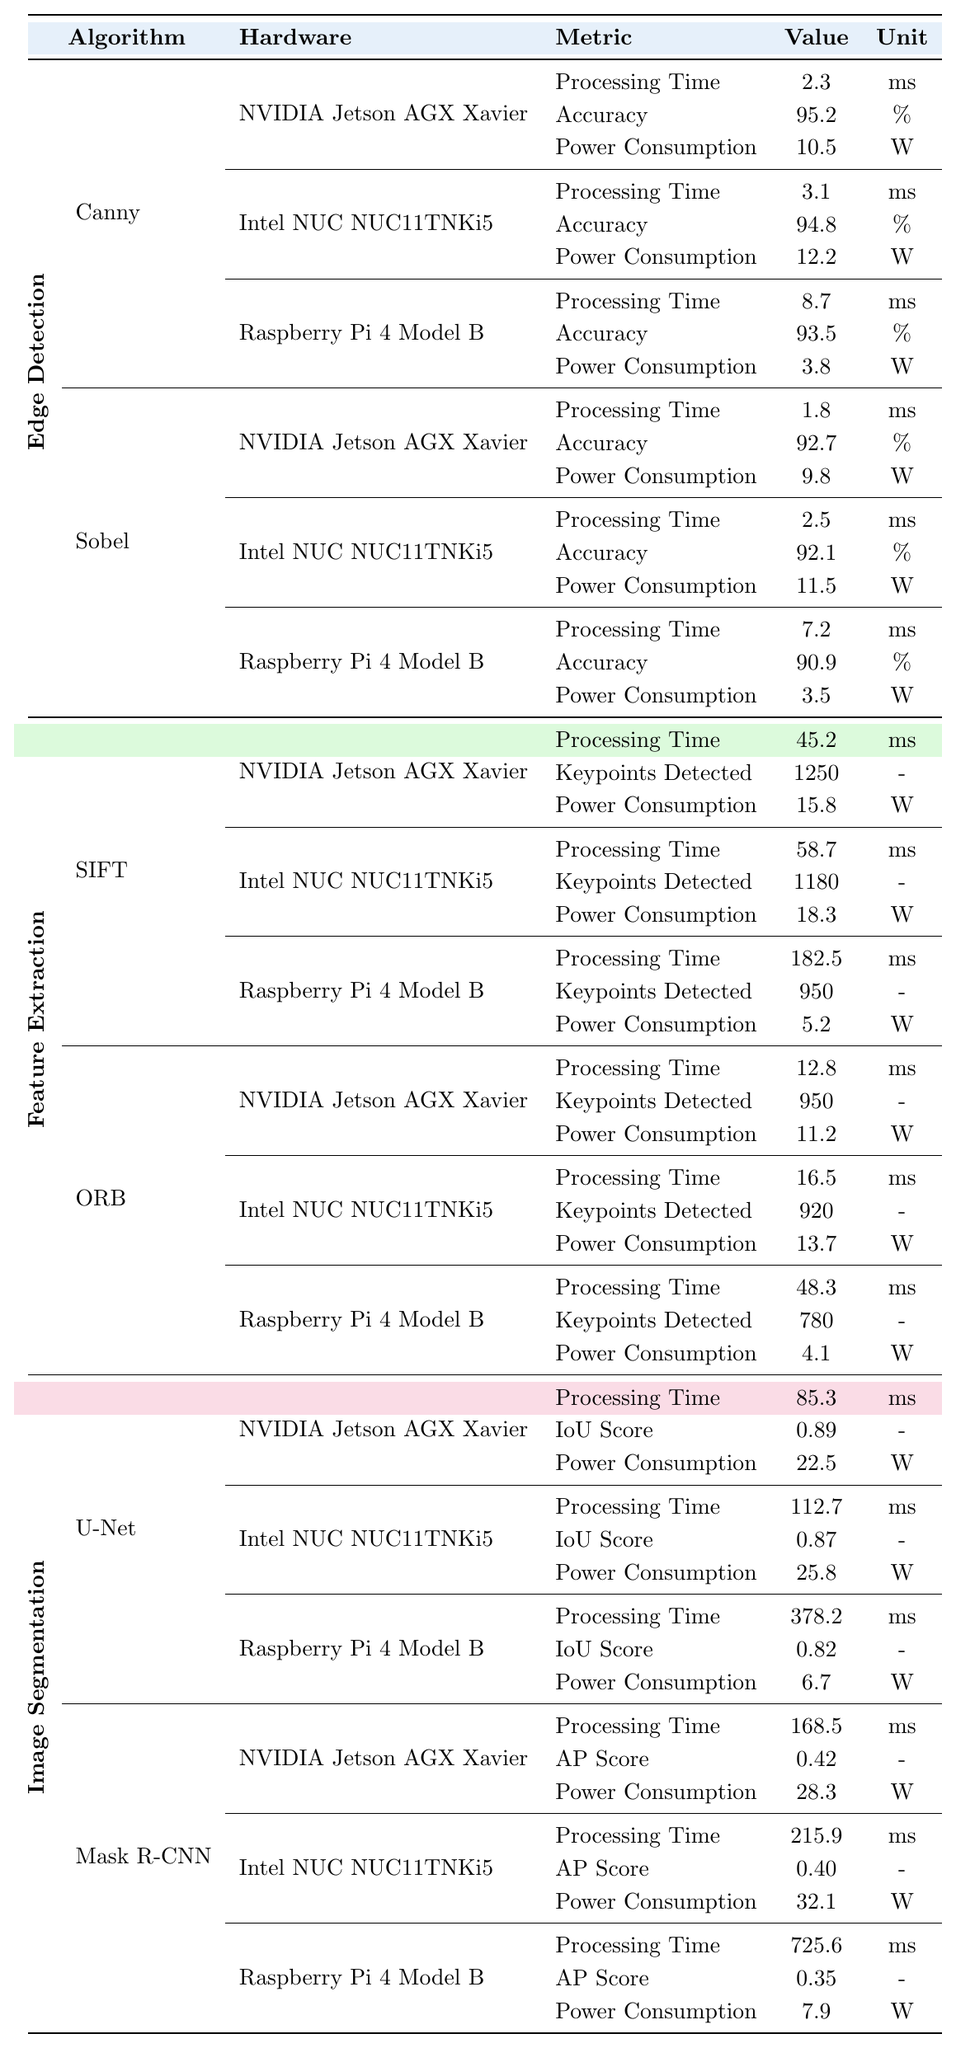What's the processing time of the Canny algorithm on the NVIDIA Jetson AGX Xavier? The table shows that the processing time for the Canny algorithm on the NVIDIA Jetson AGX Xavier is 2.3 ms.
Answer: 2.3 ms Which algorithm has the highest accuracy among the edge detection algorithms? By comparing the accuracy values for Canny (95.2%), and Sobel (92.7%), the Canny algorithm has the highest accuracy among edge detection algorithms.
Answer: Canny What is the power consumption for the Mask R-CNN algorithm on the Raspberry Pi 4 Model B? The power consumption for the Mask R-CNN algorithm on the Raspberry Pi 4 Model B is noted as 7.9 W in the table.
Answer: 7.9 W What is the difference in processing time between the SIFT algorithm on the NVIDIA Jetson AGX Xavier and the Raspberry Pi 4 Model B? The processing time for SIFT on the Jetson is 45.2 ms and on the Raspberry Pi is 182.5 ms. The difference is 182.5 - 45.2 = 137.3 ms.
Answer: 137.3 ms On which platform does the U-Net algorithm show the highest IoU Score, and what is that score? The U-Net algorithm's IoU Score is listed as 0.89 on the NVIDIA Jetson AGX Xavier, which is higher than the scores on the other platforms (0.87 on Intel NUC and 0.82 on Raspberry Pi).
Answer: NVIDIA Jetson AGX Xavier, 0.89 If we were to average the processing times of the Canny and Sobel algorithms across the three platforms, what would that average be? The processing times are: Canny (2.3 ms, 3.1 ms, 8.7 ms) and Sobel (1.8 ms, 2.5 ms, 7.2 ms). The average is calculated as (2.3 + 3.1 + 8.7 + 1.8 + 2.5 + 7.2) / 6 = 4.38 ms.
Answer: 4.38 ms For which algorithm is the power consumption on the Intel NUC the highest and what is that value? The Mask R-CNN algorithm shows the highest power consumption of 32.1 W on the Intel NUC NUC11TNKi5, compared to other algorithms on the same platform.
Answer: Mask R-CNN, 32.1 W Which hardware platform performs the fastest for the ORB algorithm, and what is its processing time? The NVIDIA Jetson AGX Xavier performs the fastest for the ORB algorithm with a processing time of 12.8 ms, as seen in the comparison with Intel NUC and Raspberry Pi.
Answer: NVIDIA Jetson AGX Xavier, 12.8 ms Is it true that the Raspberry Pi 4 Model B has a processing time less than 200 ms for all image segmentation algorithms? The Raspberry Pi 4 Model B has processing times of 378.2 ms for U-Net and 725.6 ms for Mask R-CNN, so it is not true that all are under 200 ms.
Answer: No What is the total power consumption of the Edge Detection algorithms on the NVIDIA Jetson AGX Xavier? The total power consumption is 10.5 W (Canny) + 9.8 W (Sobel) = 20.3 W for the Edge Detection algorithms on the NVIDIA Jetson AGX Xavier.
Answer: 20.3 W 